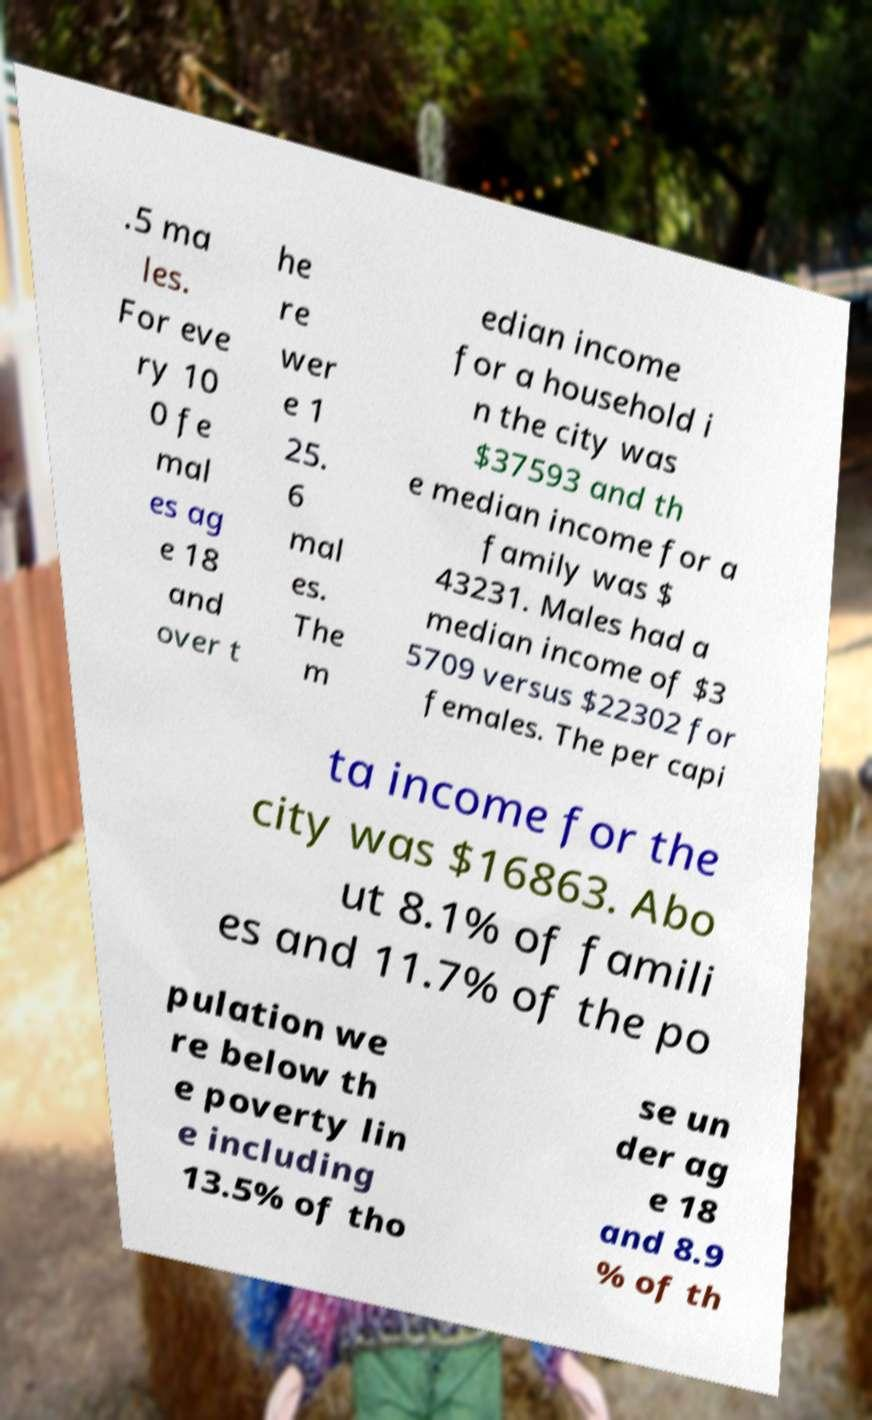Can you accurately transcribe the text from the provided image for me? .5 ma les. For eve ry 10 0 fe mal es ag e 18 and over t he re wer e 1 25. 6 mal es. The m edian income for a household i n the city was $37593 and th e median income for a family was $ 43231. Males had a median income of $3 5709 versus $22302 for females. The per capi ta income for the city was $16863. Abo ut 8.1% of famili es and 11.7% of the po pulation we re below th e poverty lin e including 13.5% of tho se un der ag e 18 and 8.9 % of th 